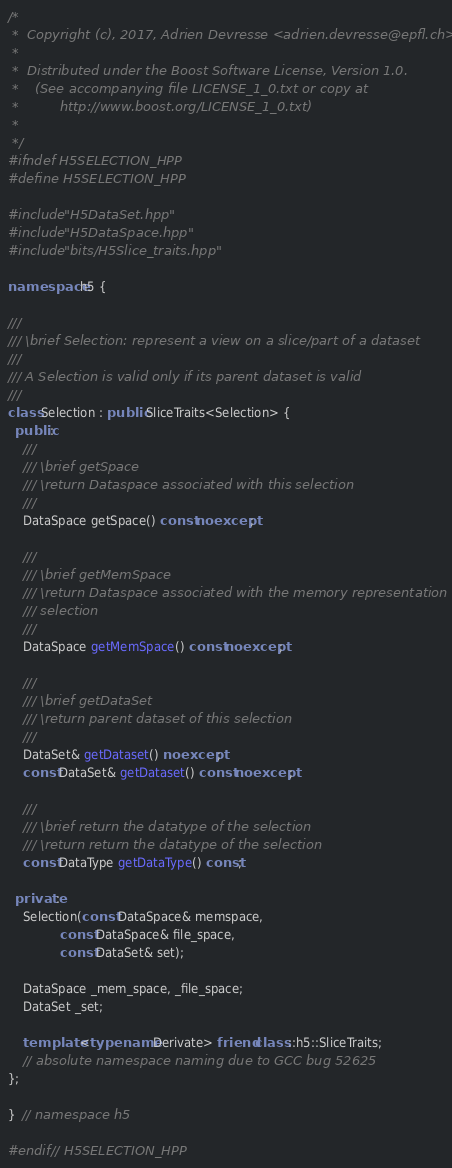<code> <loc_0><loc_0><loc_500><loc_500><_C++_>/*
 *  Copyright (c), 2017, Adrien Devresse <adrien.devresse@epfl.ch>
 *
 *  Distributed under the Boost Software License, Version 1.0.
 *    (See accompanying file LICENSE_1_0.txt or copy at
 *          http://www.boost.org/LICENSE_1_0.txt)
 *
 */
#ifndef H5SELECTION_HPP
#define H5SELECTION_HPP

#include "H5DataSet.hpp"
#include "H5DataSpace.hpp"
#include "bits/H5Slice_traits.hpp"

namespace h5 {

///
/// \brief Selection: represent a view on a slice/part of a dataset
///
/// A Selection is valid only if its parent dataset is valid
///
class Selection : public SliceTraits<Selection> {
  public:
    ///
    /// \brief getSpace
    /// \return Dataspace associated with this selection
    ///
    DataSpace getSpace() const noexcept;

    ///
    /// \brief getMemSpace
    /// \return Dataspace associated with the memory representation of this
    /// selection
    ///
    DataSpace getMemSpace() const noexcept;

    ///
    /// \brief getDataSet
    /// \return parent dataset of this selection
    ///
    DataSet& getDataset() noexcept;
    const DataSet& getDataset() const noexcept;

    ///
    /// \brief return the datatype of the selection
    /// \return return the datatype of the selection
    const DataType getDataType() const;

  private:
    Selection(const DataSpace& memspace,
              const DataSpace& file_space,
              const DataSet& set);

    DataSpace _mem_space, _file_space;
    DataSet _set;

    template <typename Derivate> friend class ::h5::SliceTraits;
    // absolute namespace naming due to GCC bug 52625
};

}  // namespace h5

#endif // H5SELECTION_HPP
</code> 